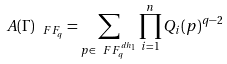<formula> <loc_0><loc_0><loc_500><loc_500>A ( \Gamma ) _ { \ F F _ { q } } = \sum _ { p \in \ F F _ { q } ^ { d h _ { 1 } } } \prod _ { i = 1 } ^ { n } Q _ { i } ( p ) ^ { q - 2 }</formula> 